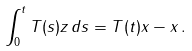<formula> <loc_0><loc_0><loc_500><loc_500>\int _ { 0 } ^ { t } T ( s ) z \, d s = T ( t ) x - x \, .</formula> 